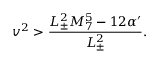Convert formula to latex. <formula><loc_0><loc_0><loc_500><loc_500>v ^ { 2 } > \frac { L _ { \pm } ^ { 2 } M _ { 7 } ^ { 5 } - 1 2 \alpha ^ { \prime } } { L _ { \pm } ^ { 2 } } .</formula> 